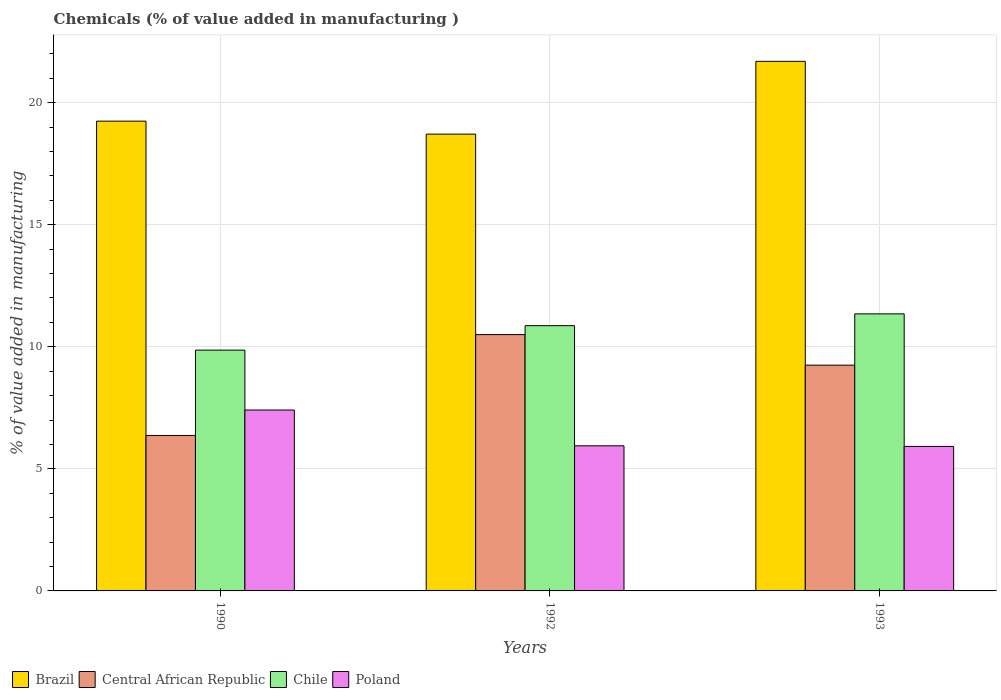How many groups of bars are there?
Offer a terse response. 3. How many bars are there on the 1st tick from the right?
Your answer should be very brief. 4. What is the label of the 3rd group of bars from the left?
Your answer should be compact. 1993. In how many cases, is the number of bars for a given year not equal to the number of legend labels?
Your response must be concise. 0. What is the value added in manufacturing chemicals in Chile in 1992?
Provide a short and direct response. 10.86. Across all years, what is the maximum value added in manufacturing chemicals in Brazil?
Provide a succinct answer. 21.69. Across all years, what is the minimum value added in manufacturing chemicals in Chile?
Make the answer very short. 9.86. In which year was the value added in manufacturing chemicals in Brazil maximum?
Offer a terse response. 1993. What is the total value added in manufacturing chemicals in Poland in the graph?
Make the answer very short. 19.27. What is the difference between the value added in manufacturing chemicals in Brazil in 1990 and that in 1993?
Offer a very short reply. -2.45. What is the difference between the value added in manufacturing chemicals in Poland in 1993 and the value added in manufacturing chemicals in Brazil in 1990?
Provide a short and direct response. -13.32. What is the average value added in manufacturing chemicals in Central African Republic per year?
Provide a succinct answer. 8.7. In the year 1993, what is the difference between the value added in manufacturing chemicals in Central African Republic and value added in manufacturing chemicals in Chile?
Your answer should be compact. -2.1. In how many years, is the value added in manufacturing chemicals in Chile greater than 9 %?
Provide a succinct answer. 3. What is the ratio of the value added in manufacturing chemicals in Chile in 1992 to that in 1993?
Provide a succinct answer. 0.96. Is the value added in manufacturing chemicals in Central African Republic in 1990 less than that in 1993?
Your response must be concise. Yes. Is the difference between the value added in manufacturing chemicals in Central African Republic in 1990 and 1992 greater than the difference between the value added in manufacturing chemicals in Chile in 1990 and 1992?
Give a very brief answer. No. What is the difference between the highest and the second highest value added in manufacturing chemicals in Chile?
Your answer should be compact. 0.48. What is the difference between the highest and the lowest value added in manufacturing chemicals in Central African Republic?
Provide a succinct answer. 4.13. Is the sum of the value added in manufacturing chemicals in Brazil in 1990 and 1993 greater than the maximum value added in manufacturing chemicals in Central African Republic across all years?
Provide a short and direct response. Yes. What does the 3rd bar from the right in 1992 represents?
Your answer should be very brief. Central African Republic. Are all the bars in the graph horizontal?
Ensure brevity in your answer.  No. How many years are there in the graph?
Your answer should be compact. 3. What is the difference between two consecutive major ticks on the Y-axis?
Ensure brevity in your answer.  5. Are the values on the major ticks of Y-axis written in scientific E-notation?
Your response must be concise. No. Does the graph contain any zero values?
Keep it short and to the point. No. Where does the legend appear in the graph?
Make the answer very short. Bottom left. How many legend labels are there?
Offer a very short reply. 4. What is the title of the graph?
Ensure brevity in your answer.  Chemicals (% of value added in manufacturing ). Does "Kenya" appear as one of the legend labels in the graph?
Keep it short and to the point. No. What is the label or title of the X-axis?
Offer a very short reply. Years. What is the label or title of the Y-axis?
Offer a very short reply. % of value added in manufacturing. What is the % of value added in manufacturing of Brazil in 1990?
Offer a very short reply. 19.24. What is the % of value added in manufacturing in Central African Republic in 1990?
Your answer should be very brief. 6.37. What is the % of value added in manufacturing of Chile in 1990?
Your response must be concise. 9.86. What is the % of value added in manufacturing in Poland in 1990?
Give a very brief answer. 7.41. What is the % of value added in manufacturing of Brazil in 1992?
Offer a terse response. 18.71. What is the % of value added in manufacturing of Central African Republic in 1992?
Give a very brief answer. 10.5. What is the % of value added in manufacturing in Chile in 1992?
Provide a short and direct response. 10.86. What is the % of value added in manufacturing in Poland in 1992?
Ensure brevity in your answer.  5.94. What is the % of value added in manufacturing in Brazil in 1993?
Ensure brevity in your answer.  21.69. What is the % of value added in manufacturing of Central African Republic in 1993?
Provide a short and direct response. 9.25. What is the % of value added in manufacturing in Chile in 1993?
Ensure brevity in your answer.  11.35. What is the % of value added in manufacturing in Poland in 1993?
Keep it short and to the point. 5.92. Across all years, what is the maximum % of value added in manufacturing of Brazil?
Give a very brief answer. 21.69. Across all years, what is the maximum % of value added in manufacturing of Central African Republic?
Make the answer very short. 10.5. Across all years, what is the maximum % of value added in manufacturing of Chile?
Provide a succinct answer. 11.35. Across all years, what is the maximum % of value added in manufacturing in Poland?
Your response must be concise. 7.41. Across all years, what is the minimum % of value added in manufacturing of Brazil?
Offer a very short reply. 18.71. Across all years, what is the minimum % of value added in manufacturing in Central African Republic?
Keep it short and to the point. 6.37. Across all years, what is the minimum % of value added in manufacturing in Chile?
Offer a terse response. 9.86. Across all years, what is the minimum % of value added in manufacturing of Poland?
Provide a short and direct response. 5.92. What is the total % of value added in manufacturing of Brazil in the graph?
Offer a terse response. 59.64. What is the total % of value added in manufacturing in Central African Republic in the graph?
Offer a very short reply. 26.11. What is the total % of value added in manufacturing in Chile in the graph?
Offer a very short reply. 32.07. What is the total % of value added in manufacturing of Poland in the graph?
Keep it short and to the point. 19.27. What is the difference between the % of value added in manufacturing in Brazil in 1990 and that in 1992?
Provide a succinct answer. 0.53. What is the difference between the % of value added in manufacturing of Central African Republic in 1990 and that in 1992?
Make the answer very short. -4.13. What is the difference between the % of value added in manufacturing in Chile in 1990 and that in 1992?
Your answer should be compact. -1. What is the difference between the % of value added in manufacturing in Poland in 1990 and that in 1992?
Give a very brief answer. 1.47. What is the difference between the % of value added in manufacturing of Brazil in 1990 and that in 1993?
Provide a succinct answer. -2.45. What is the difference between the % of value added in manufacturing of Central African Republic in 1990 and that in 1993?
Keep it short and to the point. -2.88. What is the difference between the % of value added in manufacturing of Chile in 1990 and that in 1993?
Your response must be concise. -1.48. What is the difference between the % of value added in manufacturing in Poland in 1990 and that in 1993?
Your answer should be very brief. 1.49. What is the difference between the % of value added in manufacturing in Brazil in 1992 and that in 1993?
Your answer should be very brief. -2.98. What is the difference between the % of value added in manufacturing in Central African Republic in 1992 and that in 1993?
Offer a very short reply. 1.25. What is the difference between the % of value added in manufacturing in Chile in 1992 and that in 1993?
Ensure brevity in your answer.  -0.48. What is the difference between the % of value added in manufacturing in Poland in 1992 and that in 1993?
Make the answer very short. 0.03. What is the difference between the % of value added in manufacturing of Brazil in 1990 and the % of value added in manufacturing of Central African Republic in 1992?
Offer a terse response. 8.74. What is the difference between the % of value added in manufacturing in Brazil in 1990 and the % of value added in manufacturing in Chile in 1992?
Give a very brief answer. 8.38. What is the difference between the % of value added in manufacturing in Brazil in 1990 and the % of value added in manufacturing in Poland in 1992?
Your answer should be very brief. 13.3. What is the difference between the % of value added in manufacturing in Central African Republic in 1990 and the % of value added in manufacturing in Chile in 1992?
Offer a terse response. -4.5. What is the difference between the % of value added in manufacturing in Central African Republic in 1990 and the % of value added in manufacturing in Poland in 1992?
Make the answer very short. 0.42. What is the difference between the % of value added in manufacturing of Chile in 1990 and the % of value added in manufacturing of Poland in 1992?
Give a very brief answer. 3.92. What is the difference between the % of value added in manufacturing of Brazil in 1990 and the % of value added in manufacturing of Central African Republic in 1993?
Ensure brevity in your answer.  9.99. What is the difference between the % of value added in manufacturing of Brazil in 1990 and the % of value added in manufacturing of Chile in 1993?
Provide a short and direct response. 7.89. What is the difference between the % of value added in manufacturing of Brazil in 1990 and the % of value added in manufacturing of Poland in 1993?
Your answer should be very brief. 13.32. What is the difference between the % of value added in manufacturing in Central African Republic in 1990 and the % of value added in manufacturing in Chile in 1993?
Make the answer very short. -4.98. What is the difference between the % of value added in manufacturing in Central African Republic in 1990 and the % of value added in manufacturing in Poland in 1993?
Provide a short and direct response. 0.45. What is the difference between the % of value added in manufacturing in Chile in 1990 and the % of value added in manufacturing in Poland in 1993?
Your response must be concise. 3.94. What is the difference between the % of value added in manufacturing in Brazil in 1992 and the % of value added in manufacturing in Central African Republic in 1993?
Ensure brevity in your answer.  9.46. What is the difference between the % of value added in manufacturing in Brazil in 1992 and the % of value added in manufacturing in Chile in 1993?
Keep it short and to the point. 7.36. What is the difference between the % of value added in manufacturing in Brazil in 1992 and the % of value added in manufacturing in Poland in 1993?
Make the answer very short. 12.79. What is the difference between the % of value added in manufacturing of Central African Republic in 1992 and the % of value added in manufacturing of Chile in 1993?
Keep it short and to the point. -0.85. What is the difference between the % of value added in manufacturing of Central African Republic in 1992 and the % of value added in manufacturing of Poland in 1993?
Your response must be concise. 4.58. What is the difference between the % of value added in manufacturing of Chile in 1992 and the % of value added in manufacturing of Poland in 1993?
Ensure brevity in your answer.  4.95. What is the average % of value added in manufacturing in Brazil per year?
Make the answer very short. 19.88. What is the average % of value added in manufacturing in Central African Republic per year?
Your answer should be very brief. 8.7. What is the average % of value added in manufacturing of Chile per year?
Your response must be concise. 10.69. What is the average % of value added in manufacturing of Poland per year?
Your response must be concise. 6.42. In the year 1990, what is the difference between the % of value added in manufacturing in Brazil and % of value added in manufacturing in Central African Republic?
Your response must be concise. 12.87. In the year 1990, what is the difference between the % of value added in manufacturing in Brazil and % of value added in manufacturing in Chile?
Your answer should be very brief. 9.38. In the year 1990, what is the difference between the % of value added in manufacturing of Brazil and % of value added in manufacturing of Poland?
Your answer should be compact. 11.83. In the year 1990, what is the difference between the % of value added in manufacturing of Central African Republic and % of value added in manufacturing of Chile?
Give a very brief answer. -3.5. In the year 1990, what is the difference between the % of value added in manufacturing of Central African Republic and % of value added in manufacturing of Poland?
Your answer should be very brief. -1.04. In the year 1990, what is the difference between the % of value added in manufacturing of Chile and % of value added in manufacturing of Poland?
Make the answer very short. 2.45. In the year 1992, what is the difference between the % of value added in manufacturing in Brazil and % of value added in manufacturing in Central African Republic?
Ensure brevity in your answer.  8.21. In the year 1992, what is the difference between the % of value added in manufacturing of Brazil and % of value added in manufacturing of Chile?
Your answer should be very brief. 7.84. In the year 1992, what is the difference between the % of value added in manufacturing in Brazil and % of value added in manufacturing in Poland?
Your answer should be very brief. 12.76. In the year 1992, what is the difference between the % of value added in manufacturing in Central African Republic and % of value added in manufacturing in Chile?
Your answer should be very brief. -0.37. In the year 1992, what is the difference between the % of value added in manufacturing of Central African Republic and % of value added in manufacturing of Poland?
Provide a succinct answer. 4.55. In the year 1992, what is the difference between the % of value added in manufacturing of Chile and % of value added in manufacturing of Poland?
Keep it short and to the point. 4.92. In the year 1993, what is the difference between the % of value added in manufacturing in Brazil and % of value added in manufacturing in Central African Republic?
Keep it short and to the point. 12.44. In the year 1993, what is the difference between the % of value added in manufacturing in Brazil and % of value added in manufacturing in Chile?
Keep it short and to the point. 10.34. In the year 1993, what is the difference between the % of value added in manufacturing of Brazil and % of value added in manufacturing of Poland?
Your response must be concise. 15.77. In the year 1993, what is the difference between the % of value added in manufacturing in Central African Republic and % of value added in manufacturing in Chile?
Your answer should be very brief. -2.1. In the year 1993, what is the difference between the % of value added in manufacturing in Central African Republic and % of value added in manufacturing in Poland?
Provide a short and direct response. 3.33. In the year 1993, what is the difference between the % of value added in manufacturing in Chile and % of value added in manufacturing in Poland?
Your answer should be very brief. 5.43. What is the ratio of the % of value added in manufacturing of Brazil in 1990 to that in 1992?
Your answer should be compact. 1.03. What is the ratio of the % of value added in manufacturing of Central African Republic in 1990 to that in 1992?
Your answer should be compact. 0.61. What is the ratio of the % of value added in manufacturing of Chile in 1990 to that in 1992?
Your response must be concise. 0.91. What is the ratio of the % of value added in manufacturing in Poland in 1990 to that in 1992?
Your answer should be very brief. 1.25. What is the ratio of the % of value added in manufacturing in Brazil in 1990 to that in 1993?
Your answer should be very brief. 0.89. What is the ratio of the % of value added in manufacturing of Central African Republic in 1990 to that in 1993?
Make the answer very short. 0.69. What is the ratio of the % of value added in manufacturing in Chile in 1990 to that in 1993?
Offer a very short reply. 0.87. What is the ratio of the % of value added in manufacturing of Poland in 1990 to that in 1993?
Your response must be concise. 1.25. What is the ratio of the % of value added in manufacturing in Brazil in 1992 to that in 1993?
Your answer should be compact. 0.86. What is the ratio of the % of value added in manufacturing in Central African Republic in 1992 to that in 1993?
Give a very brief answer. 1.14. What is the ratio of the % of value added in manufacturing in Chile in 1992 to that in 1993?
Your answer should be very brief. 0.96. What is the ratio of the % of value added in manufacturing in Poland in 1992 to that in 1993?
Provide a succinct answer. 1. What is the difference between the highest and the second highest % of value added in manufacturing in Brazil?
Your response must be concise. 2.45. What is the difference between the highest and the second highest % of value added in manufacturing in Central African Republic?
Provide a short and direct response. 1.25. What is the difference between the highest and the second highest % of value added in manufacturing of Chile?
Offer a terse response. 0.48. What is the difference between the highest and the second highest % of value added in manufacturing of Poland?
Offer a very short reply. 1.47. What is the difference between the highest and the lowest % of value added in manufacturing in Brazil?
Your answer should be very brief. 2.98. What is the difference between the highest and the lowest % of value added in manufacturing in Central African Republic?
Ensure brevity in your answer.  4.13. What is the difference between the highest and the lowest % of value added in manufacturing in Chile?
Offer a very short reply. 1.48. What is the difference between the highest and the lowest % of value added in manufacturing in Poland?
Give a very brief answer. 1.49. 